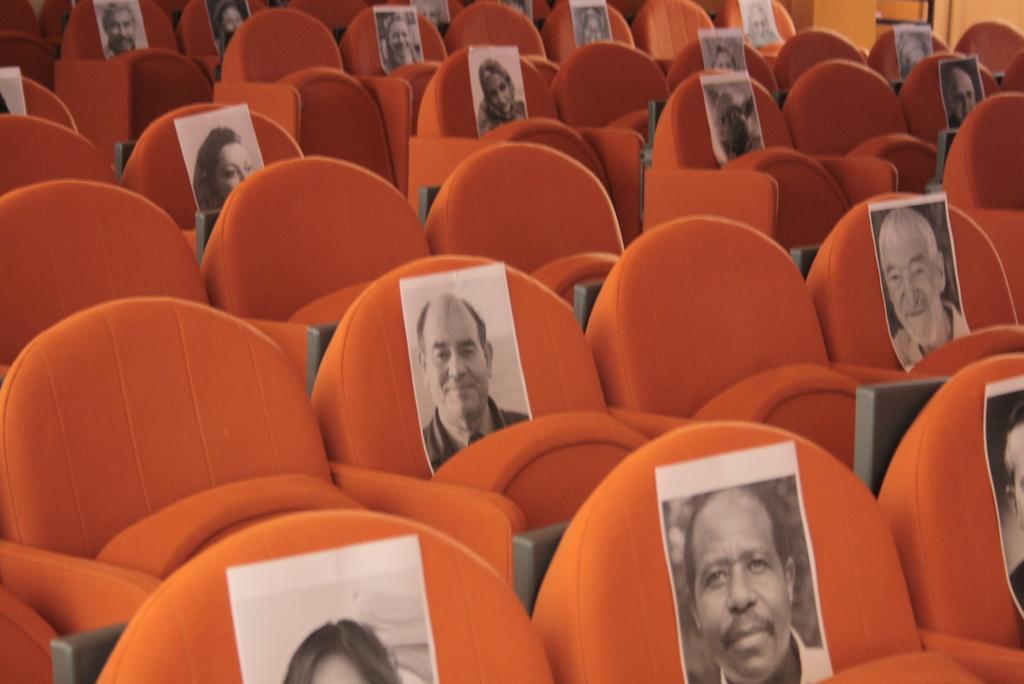Describe this image in one or two sentences. In the image there are many seats with photo printed on it. 